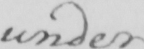What does this handwritten line say? under 